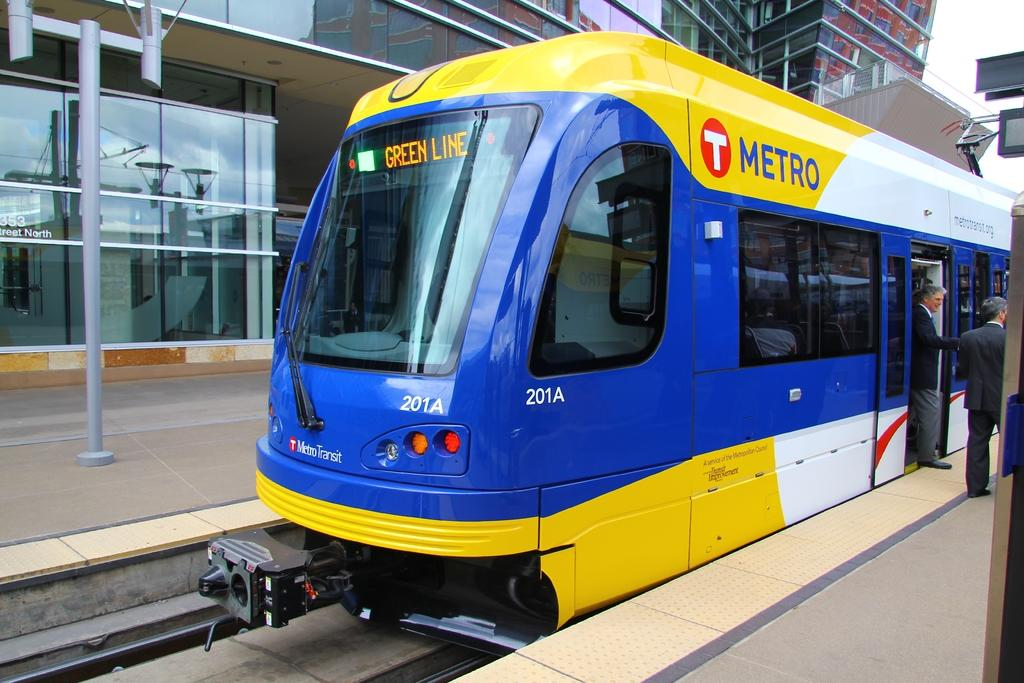What is the main subject of the image? The main subject of the image is a train on a railway track. Who or what else can be seen in the image? Two men are standing in the image. What are the men wearing? The men are wearing suits. What can be seen in the background of the image? There are glass buildings in the background of the image. Can you see any kissing happening between the two men in the image? There is no kissing happening between the two men in the image. How many feet are visible in the image? The number of feet visible in the image cannot be determined from the provided facts. 